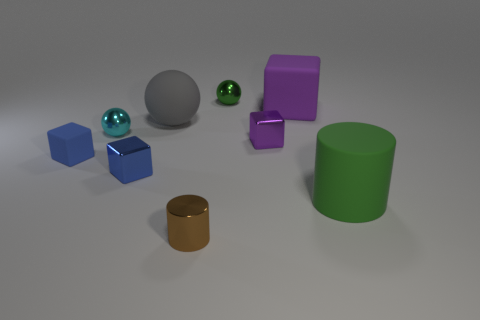The thing that is the same color as the big rubber block is what shape?
Provide a short and direct response. Cube. How many other objects are the same material as the gray sphere?
Give a very brief answer. 3. How many blue things are there?
Give a very brief answer. 2. There is another large object that is the same shape as the cyan metal object; what material is it?
Keep it short and to the point. Rubber. Are the cube that is in front of the blue matte thing and the small brown thing made of the same material?
Offer a very short reply. Yes. Is the number of big spheres on the left side of the big gray object greater than the number of gray rubber things behind the green metallic sphere?
Ensure brevity in your answer.  No. The purple rubber thing is what size?
Make the answer very short. Large. There is a large purple thing that is made of the same material as the big green thing; what shape is it?
Make the answer very short. Cube. Does the metallic thing that is in front of the matte cylinder have the same shape as the tiny cyan object?
Offer a terse response. No. What number of objects are either blue shiny blocks or tiny red rubber cylinders?
Provide a succinct answer. 1. 